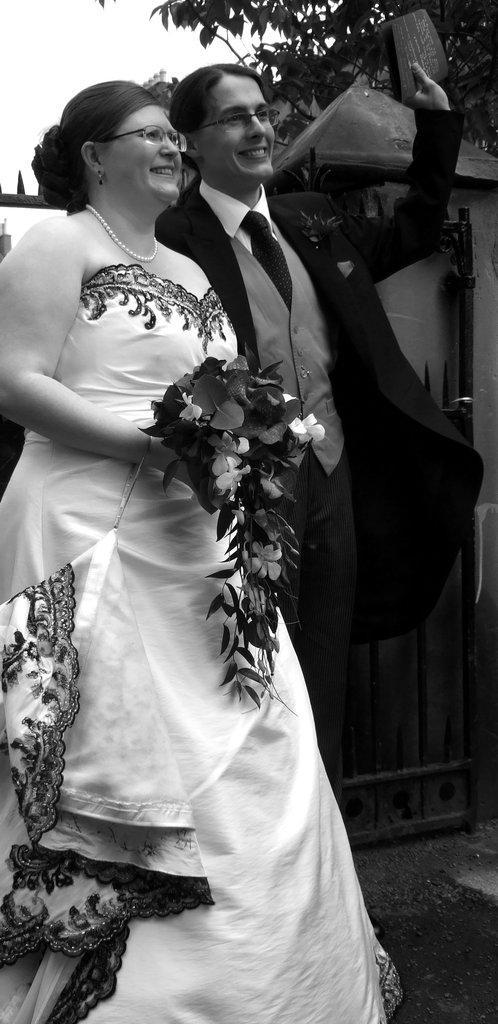Please provide a concise description of this image. In this image I can see there are persons standing and holding a card and flowers. And at the back there is a gate in the wall. And there is a tree and a sky. 